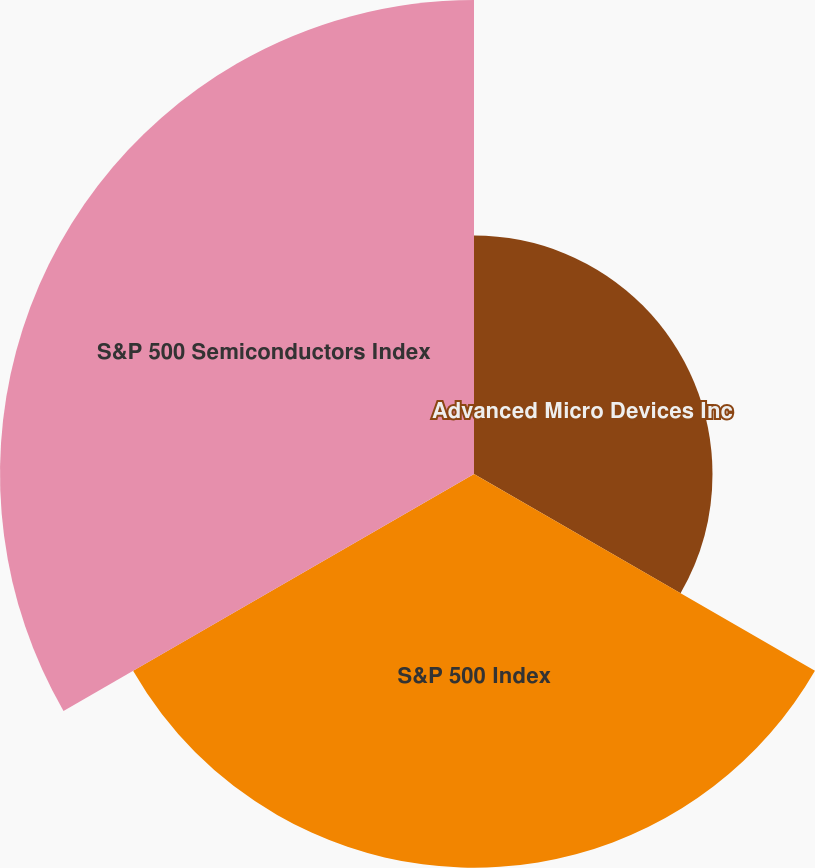<chart> <loc_0><loc_0><loc_500><loc_500><pie_chart><fcel>Advanced Micro Devices Inc<fcel>S&P 500 Index<fcel>S&P 500 Semiconductors Index<nl><fcel>21.56%<fcel>35.59%<fcel>42.85%<nl></chart> 